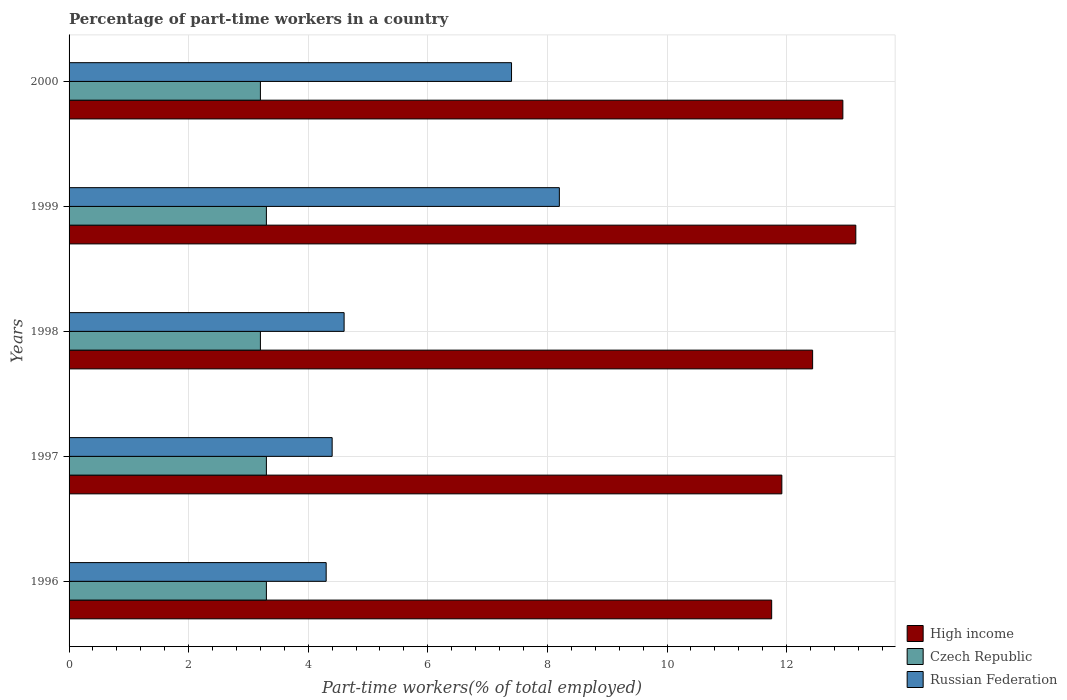How many different coloured bars are there?
Make the answer very short. 3. How many groups of bars are there?
Provide a succinct answer. 5. Are the number of bars on each tick of the Y-axis equal?
Your answer should be compact. Yes. How many bars are there on the 2nd tick from the top?
Ensure brevity in your answer.  3. How many bars are there on the 2nd tick from the bottom?
Your response must be concise. 3. What is the label of the 5th group of bars from the top?
Your response must be concise. 1996. In how many cases, is the number of bars for a given year not equal to the number of legend labels?
Keep it short and to the point. 0. What is the percentage of part-time workers in Russian Federation in 1996?
Give a very brief answer. 4.3. Across all years, what is the maximum percentage of part-time workers in Russian Federation?
Your answer should be very brief. 8.2. Across all years, what is the minimum percentage of part-time workers in High income?
Give a very brief answer. 11.75. In which year was the percentage of part-time workers in High income maximum?
Make the answer very short. 1999. In which year was the percentage of part-time workers in Czech Republic minimum?
Give a very brief answer. 1998. What is the total percentage of part-time workers in Czech Republic in the graph?
Provide a short and direct response. 16.3. What is the difference between the percentage of part-time workers in Russian Federation in 1997 and that in 1998?
Ensure brevity in your answer.  -0.2. What is the difference between the percentage of part-time workers in High income in 1996 and the percentage of part-time workers in Russian Federation in 2000?
Your response must be concise. 4.35. What is the average percentage of part-time workers in Czech Republic per year?
Your answer should be compact. 3.26. In the year 1996, what is the difference between the percentage of part-time workers in Czech Republic and percentage of part-time workers in Russian Federation?
Keep it short and to the point. -1. What is the ratio of the percentage of part-time workers in Czech Republic in 1999 to that in 2000?
Offer a very short reply. 1.03. Is the difference between the percentage of part-time workers in Czech Republic in 1998 and 1999 greater than the difference between the percentage of part-time workers in Russian Federation in 1998 and 1999?
Your response must be concise. Yes. What is the difference between the highest and the second highest percentage of part-time workers in Russian Federation?
Your answer should be compact. 0.8. What is the difference between the highest and the lowest percentage of part-time workers in Russian Federation?
Your response must be concise. 3.9. What does the 2nd bar from the top in 2000 represents?
Ensure brevity in your answer.  Czech Republic. What does the 3rd bar from the bottom in 1998 represents?
Provide a short and direct response. Russian Federation. How many bars are there?
Make the answer very short. 15. Are the values on the major ticks of X-axis written in scientific E-notation?
Give a very brief answer. No. Does the graph contain any zero values?
Offer a terse response. No. Does the graph contain grids?
Offer a terse response. Yes. What is the title of the graph?
Make the answer very short. Percentage of part-time workers in a country. What is the label or title of the X-axis?
Keep it short and to the point. Part-time workers(% of total employed). What is the label or title of the Y-axis?
Give a very brief answer. Years. What is the Part-time workers(% of total employed) in High income in 1996?
Your response must be concise. 11.75. What is the Part-time workers(% of total employed) in Czech Republic in 1996?
Give a very brief answer. 3.3. What is the Part-time workers(% of total employed) in Russian Federation in 1996?
Provide a succinct answer. 4.3. What is the Part-time workers(% of total employed) of High income in 1997?
Provide a short and direct response. 11.92. What is the Part-time workers(% of total employed) of Czech Republic in 1997?
Offer a terse response. 3.3. What is the Part-time workers(% of total employed) of Russian Federation in 1997?
Provide a short and direct response. 4.4. What is the Part-time workers(% of total employed) in High income in 1998?
Your answer should be compact. 12.44. What is the Part-time workers(% of total employed) of Czech Republic in 1998?
Offer a very short reply. 3.2. What is the Part-time workers(% of total employed) of Russian Federation in 1998?
Make the answer very short. 4.6. What is the Part-time workers(% of total employed) of High income in 1999?
Offer a very short reply. 13.16. What is the Part-time workers(% of total employed) in Czech Republic in 1999?
Your answer should be compact. 3.3. What is the Part-time workers(% of total employed) in Russian Federation in 1999?
Make the answer very short. 8.2. What is the Part-time workers(% of total employed) of High income in 2000?
Make the answer very short. 12.94. What is the Part-time workers(% of total employed) of Czech Republic in 2000?
Make the answer very short. 3.2. What is the Part-time workers(% of total employed) of Russian Federation in 2000?
Your response must be concise. 7.4. Across all years, what is the maximum Part-time workers(% of total employed) of High income?
Keep it short and to the point. 13.16. Across all years, what is the maximum Part-time workers(% of total employed) in Czech Republic?
Make the answer very short. 3.3. Across all years, what is the maximum Part-time workers(% of total employed) in Russian Federation?
Offer a very short reply. 8.2. Across all years, what is the minimum Part-time workers(% of total employed) of High income?
Make the answer very short. 11.75. Across all years, what is the minimum Part-time workers(% of total employed) of Czech Republic?
Provide a short and direct response. 3.2. Across all years, what is the minimum Part-time workers(% of total employed) in Russian Federation?
Your answer should be very brief. 4.3. What is the total Part-time workers(% of total employed) in High income in the graph?
Your answer should be compact. 62.21. What is the total Part-time workers(% of total employed) of Czech Republic in the graph?
Your answer should be compact. 16.3. What is the total Part-time workers(% of total employed) in Russian Federation in the graph?
Your response must be concise. 28.9. What is the difference between the Part-time workers(% of total employed) of High income in 1996 and that in 1997?
Your response must be concise. -0.17. What is the difference between the Part-time workers(% of total employed) of Russian Federation in 1996 and that in 1997?
Keep it short and to the point. -0.1. What is the difference between the Part-time workers(% of total employed) of High income in 1996 and that in 1998?
Offer a very short reply. -0.68. What is the difference between the Part-time workers(% of total employed) in Czech Republic in 1996 and that in 1998?
Ensure brevity in your answer.  0.1. What is the difference between the Part-time workers(% of total employed) in High income in 1996 and that in 1999?
Your answer should be compact. -1.41. What is the difference between the Part-time workers(% of total employed) of Czech Republic in 1996 and that in 1999?
Provide a succinct answer. 0. What is the difference between the Part-time workers(% of total employed) of Russian Federation in 1996 and that in 1999?
Provide a succinct answer. -3.9. What is the difference between the Part-time workers(% of total employed) in High income in 1996 and that in 2000?
Your response must be concise. -1.19. What is the difference between the Part-time workers(% of total employed) of Russian Federation in 1996 and that in 2000?
Your answer should be compact. -3.1. What is the difference between the Part-time workers(% of total employed) of High income in 1997 and that in 1998?
Your answer should be very brief. -0.51. What is the difference between the Part-time workers(% of total employed) in High income in 1997 and that in 1999?
Your answer should be compact. -1.24. What is the difference between the Part-time workers(% of total employed) of Russian Federation in 1997 and that in 1999?
Ensure brevity in your answer.  -3.8. What is the difference between the Part-time workers(% of total employed) of High income in 1997 and that in 2000?
Give a very brief answer. -1.02. What is the difference between the Part-time workers(% of total employed) in Russian Federation in 1997 and that in 2000?
Your answer should be very brief. -3. What is the difference between the Part-time workers(% of total employed) of High income in 1998 and that in 1999?
Provide a succinct answer. -0.72. What is the difference between the Part-time workers(% of total employed) in Russian Federation in 1998 and that in 1999?
Provide a succinct answer. -3.6. What is the difference between the Part-time workers(% of total employed) in High income in 1998 and that in 2000?
Your answer should be very brief. -0.51. What is the difference between the Part-time workers(% of total employed) in Czech Republic in 1998 and that in 2000?
Make the answer very short. 0. What is the difference between the Part-time workers(% of total employed) in High income in 1999 and that in 2000?
Provide a short and direct response. 0.22. What is the difference between the Part-time workers(% of total employed) of High income in 1996 and the Part-time workers(% of total employed) of Czech Republic in 1997?
Your response must be concise. 8.45. What is the difference between the Part-time workers(% of total employed) in High income in 1996 and the Part-time workers(% of total employed) in Russian Federation in 1997?
Your answer should be very brief. 7.35. What is the difference between the Part-time workers(% of total employed) of High income in 1996 and the Part-time workers(% of total employed) of Czech Republic in 1998?
Offer a terse response. 8.55. What is the difference between the Part-time workers(% of total employed) in High income in 1996 and the Part-time workers(% of total employed) in Russian Federation in 1998?
Provide a short and direct response. 7.15. What is the difference between the Part-time workers(% of total employed) in Czech Republic in 1996 and the Part-time workers(% of total employed) in Russian Federation in 1998?
Keep it short and to the point. -1.3. What is the difference between the Part-time workers(% of total employed) of High income in 1996 and the Part-time workers(% of total employed) of Czech Republic in 1999?
Ensure brevity in your answer.  8.45. What is the difference between the Part-time workers(% of total employed) in High income in 1996 and the Part-time workers(% of total employed) in Russian Federation in 1999?
Offer a very short reply. 3.55. What is the difference between the Part-time workers(% of total employed) in Czech Republic in 1996 and the Part-time workers(% of total employed) in Russian Federation in 1999?
Provide a succinct answer. -4.9. What is the difference between the Part-time workers(% of total employed) of High income in 1996 and the Part-time workers(% of total employed) of Czech Republic in 2000?
Ensure brevity in your answer.  8.55. What is the difference between the Part-time workers(% of total employed) of High income in 1996 and the Part-time workers(% of total employed) of Russian Federation in 2000?
Keep it short and to the point. 4.35. What is the difference between the Part-time workers(% of total employed) in Czech Republic in 1996 and the Part-time workers(% of total employed) in Russian Federation in 2000?
Make the answer very short. -4.1. What is the difference between the Part-time workers(% of total employed) in High income in 1997 and the Part-time workers(% of total employed) in Czech Republic in 1998?
Make the answer very short. 8.72. What is the difference between the Part-time workers(% of total employed) in High income in 1997 and the Part-time workers(% of total employed) in Russian Federation in 1998?
Your answer should be very brief. 7.32. What is the difference between the Part-time workers(% of total employed) in High income in 1997 and the Part-time workers(% of total employed) in Czech Republic in 1999?
Provide a succinct answer. 8.62. What is the difference between the Part-time workers(% of total employed) of High income in 1997 and the Part-time workers(% of total employed) of Russian Federation in 1999?
Offer a terse response. 3.72. What is the difference between the Part-time workers(% of total employed) of High income in 1997 and the Part-time workers(% of total employed) of Czech Republic in 2000?
Your answer should be compact. 8.72. What is the difference between the Part-time workers(% of total employed) in High income in 1997 and the Part-time workers(% of total employed) in Russian Federation in 2000?
Keep it short and to the point. 4.52. What is the difference between the Part-time workers(% of total employed) in High income in 1998 and the Part-time workers(% of total employed) in Czech Republic in 1999?
Keep it short and to the point. 9.14. What is the difference between the Part-time workers(% of total employed) in High income in 1998 and the Part-time workers(% of total employed) in Russian Federation in 1999?
Provide a succinct answer. 4.24. What is the difference between the Part-time workers(% of total employed) of High income in 1998 and the Part-time workers(% of total employed) of Czech Republic in 2000?
Your answer should be compact. 9.24. What is the difference between the Part-time workers(% of total employed) in High income in 1998 and the Part-time workers(% of total employed) in Russian Federation in 2000?
Ensure brevity in your answer.  5.04. What is the difference between the Part-time workers(% of total employed) of High income in 1999 and the Part-time workers(% of total employed) of Czech Republic in 2000?
Make the answer very short. 9.96. What is the difference between the Part-time workers(% of total employed) of High income in 1999 and the Part-time workers(% of total employed) of Russian Federation in 2000?
Keep it short and to the point. 5.76. What is the average Part-time workers(% of total employed) in High income per year?
Provide a succinct answer. 12.44. What is the average Part-time workers(% of total employed) in Czech Republic per year?
Offer a terse response. 3.26. What is the average Part-time workers(% of total employed) in Russian Federation per year?
Provide a succinct answer. 5.78. In the year 1996, what is the difference between the Part-time workers(% of total employed) of High income and Part-time workers(% of total employed) of Czech Republic?
Give a very brief answer. 8.45. In the year 1996, what is the difference between the Part-time workers(% of total employed) of High income and Part-time workers(% of total employed) of Russian Federation?
Your answer should be very brief. 7.45. In the year 1997, what is the difference between the Part-time workers(% of total employed) in High income and Part-time workers(% of total employed) in Czech Republic?
Your answer should be very brief. 8.62. In the year 1997, what is the difference between the Part-time workers(% of total employed) in High income and Part-time workers(% of total employed) in Russian Federation?
Your response must be concise. 7.52. In the year 1998, what is the difference between the Part-time workers(% of total employed) in High income and Part-time workers(% of total employed) in Czech Republic?
Provide a short and direct response. 9.24. In the year 1998, what is the difference between the Part-time workers(% of total employed) in High income and Part-time workers(% of total employed) in Russian Federation?
Your answer should be very brief. 7.84. In the year 1999, what is the difference between the Part-time workers(% of total employed) in High income and Part-time workers(% of total employed) in Czech Republic?
Your answer should be very brief. 9.86. In the year 1999, what is the difference between the Part-time workers(% of total employed) in High income and Part-time workers(% of total employed) in Russian Federation?
Offer a very short reply. 4.96. In the year 1999, what is the difference between the Part-time workers(% of total employed) of Czech Republic and Part-time workers(% of total employed) of Russian Federation?
Offer a very short reply. -4.9. In the year 2000, what is the difference between the Part-time workers(% of total employed) in High income and Part-time workers(% of total employed) in Czech Republic?
Your answer should be compact. 9.74. In the year 2000, what is the difference between the Part-time workers(% of total employed) in High income and Part-time workers(% of total employed) in Russian Federation?
Offer a very short reply. 5.54. In the year 2000, what is the difference between the Part-time workers(% of total employed) of Czech Republic and Part-time workers(% of total employed) of Russian Federation?
Keep it short and to the point. -4.2. What is the ratio of the Part-time workers(% of total employed) of High income in 1996 to that in 1997?
Your response must be concise. 0.99. What is the ratio of the Part-time workers(% of total employed) of Russian Federation in 1996 to that in 1997?
Make the answer very short. 0.98. What is the ratio of the Part-time workers(% of total employed) of High income in 1996 to that in 1998?
Offer a very short reply. 0.94. What is the ratio of the Part-time workers(% of total employed) of Czech Republic in 1996 to that in 1998?
Your answer should be very brief. 1.03. What is the ratio of the Part-time workers(% of total employed) of Russian Federation in 1996 to that in 1998?
Make the answer very short. 0.93. What is the ratio of the Part-time workers(% of total employed) in High income in 1996 to that in 1999?
Provide a succinct answer. 0.89. What is the ratio of the Part-time workers(% of total employed) in Czech Republic in 1996 to that in 1999?
Your answer should be compact. 1. What is the ratio of the Part-time workers(% of total employed) in Russian Federation in 1996 to that in 1999?
Make the answer very short. 0.52. What is the ratio of the Part-time workers(% of total employed) of High income in 1996 to that in 2000?
Keep it short and to the point. 0.91. What is the ratio of the Part-time workers(% of total employed) of Czech Republic in 1996 to that in 2000?
Give a very brief answer. 1.03. What is the ratio of the Part-time workers(% of total employed) in Russian Federation in 1996 to that in 2000?
Your response must be concise. 0.58. What is the ratio of the Part-time workers(% of total employed) of High income in 1997 to that in 1998?
Offer a terse response. 0.96. What is the ratio of the Part-time workers(% of total employed) in Czech Republic in 1997 to that in 1998?
Your answer should be compact. 1.03. What is the ratio of the Part-time workers(% of total employed) in Russian Federation in 1997 to that in 1998?
Ensure brevity in your answer.  0.96. What is the ratio of the Part-time workers(% of total employed) in High income in 1997 to that in 1999?
Provide a short and direct response. 0.91. What is the ratio of the Part-time workers(% of total employed) in Czech Republic in 1997 to that in 1999?
Provide a succinct answer. 1. What is the ratio of the Part-time workers(% of total employed) in Russian Federation in 1997 to that in 1999?
Your answer should be compact. 0.54. What is the ratio of the Part-time workers(% of total employed) of High income in 1997 to that in 2000?
Offer a terse response. 0.92. What is the ratio of the Part-time workers(% of total employed) of Czech Republic in 1997 to that in 2000?
Provide a succinct answer. 1.03. What is the ratio of the Part-time workers(% of total employed) in Russian Federation in 1997 to that in 2000?
Your response must be concise. 0.59. What is the ratio of the Part-time workers(% of total employed) of High income in 1998 to that in 1999?
Make the answer very short. 0.95. What is the ratio of the Part-time workers(% of total employed) of Czech Republic in 1998 to that in 1999?
Keep it short and to the point. 0.97. What is the ratio of the Part-time workers(% of total employed) in Russian Federation in 1998 to that in 1999?
Give a very brief answer. 0.56. What is the ratio of the Part-time workers(% of total employed) in High income in 1998 to that in 2000?
Offer a terse response. 0.96. What is the ratio of the Part-time workers(% of total employed) of Russian Federation in 1998 to that in 2000?
Make the answer very short. 0.62. What is the ratio of the Part-time workers(% of total employed) in High income in 1999 to that in 2000?
Ensure brevity in your answer.  1.02. What is the ratio of the Part-time workers(% of total employed) in Czech Republic in 1999 to that in 2000?
Ensure brevity in your answer.  1.03. What is the ratio of the Part-time workers(% of total employed) in Russian Federation in 1999 to that in 2000?
Give a very brief answer. 1.11. What is the difference between the highest and the second highest Part-time workers(% of total employed) of High income?
Make the answer very short. 0.22. What is the difference between the highest and the second highest Part-time workers(% of total employed) in Russian Federation?
Ensure brevity in your answer.  0.8. What is the difference between the highest and the lowest Part-time workers(% of total employed) of High income?
Your response must be concise. 1.41. What is the difference between the highest and the lowest Part-time workers(% of total employed) of Czech Republic?
Give a very brief answer. 0.1. What is the difference between the highest and the lowest Part-time workers(% of total employed) of Russian Federation?
Offer a terse response. 3.9. 